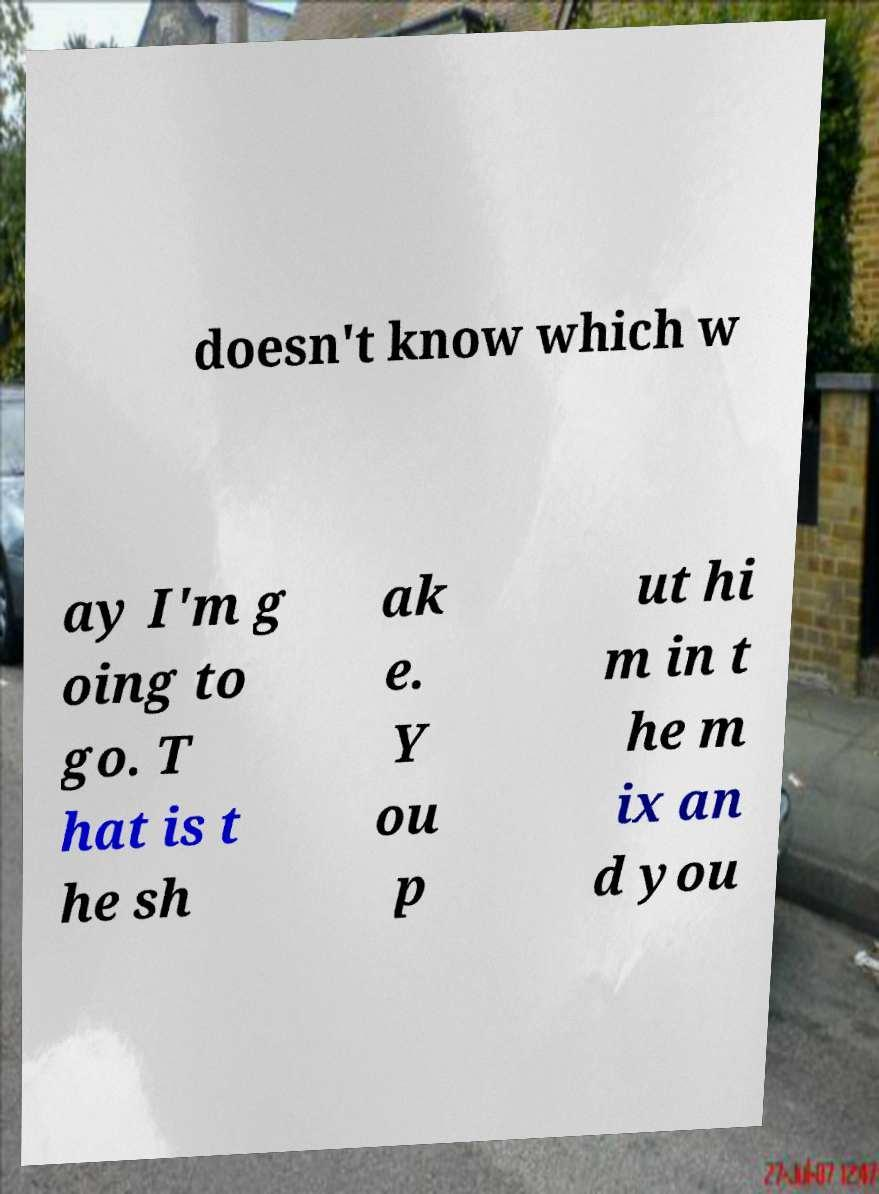What messages or text are displayed in this image? I need them in a readable, typed format. doesn't know which w ay I'm g oing to go. T hat is t he sh ak e. Y ou p ut hi m in t he m ix an d you 